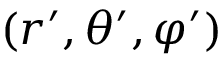Convert formula to latex. <formula><loc_0><loc_0><loc_500><loc_500>( r ^ { \prime } , \theta ^ { \prime } , \varphi ^ { \prime } )</formula> 